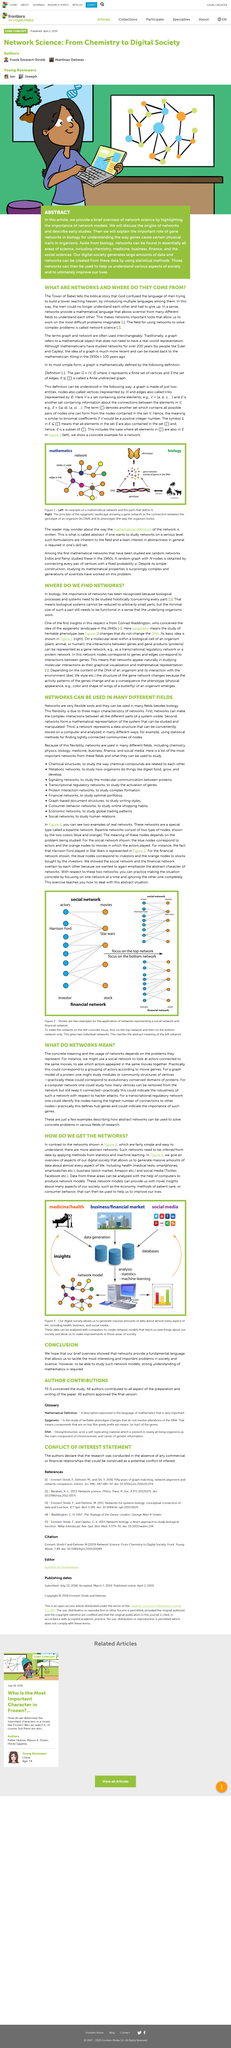Give some essential details in this illustration. Harrison Ford played the role of a Hollywood actor in Star Wars. The biblical story of the Tower of Babel, in which God confused the language of men trying to build a tower reaching heaven, by introducing multiple languages among them, teaches that language diversity is a consequence of human disobedience and divine punishment. God confused the language of humans because it prevented them from understanding each other, forcing them to give up. It is possible for network models to provide new insights into the methods of patient care, as they can offer a unique perspective on complex systems and their interactions. Networks provide a mathematical language that allows scientists from diverse fields to communicate and understand each other's research. 